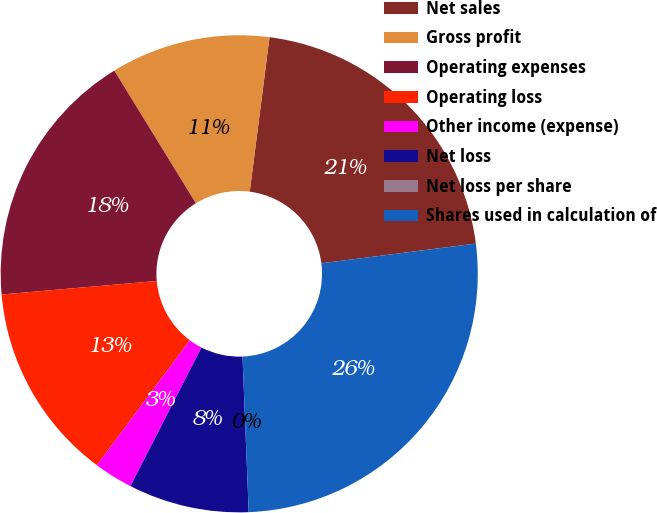<chart> <loc_0><loc_0><loc_500><loc_500><pie_chart><fcel>Net sales<fcel>Gross profit<fcel>Operating expenses<fcel>Operating loss<fcel>Other income (expense)<fcel>Net loss<fcel>Net loss per share<fcel>Shares used in calculation of<nl><fcel>20.95%<fcel>10.8%<fcel>17.61%<fcel>13.44%<fcel>2.64%<fcel>8.17%<fcel>0.0%<fcel>26.39%<nl></chart> 